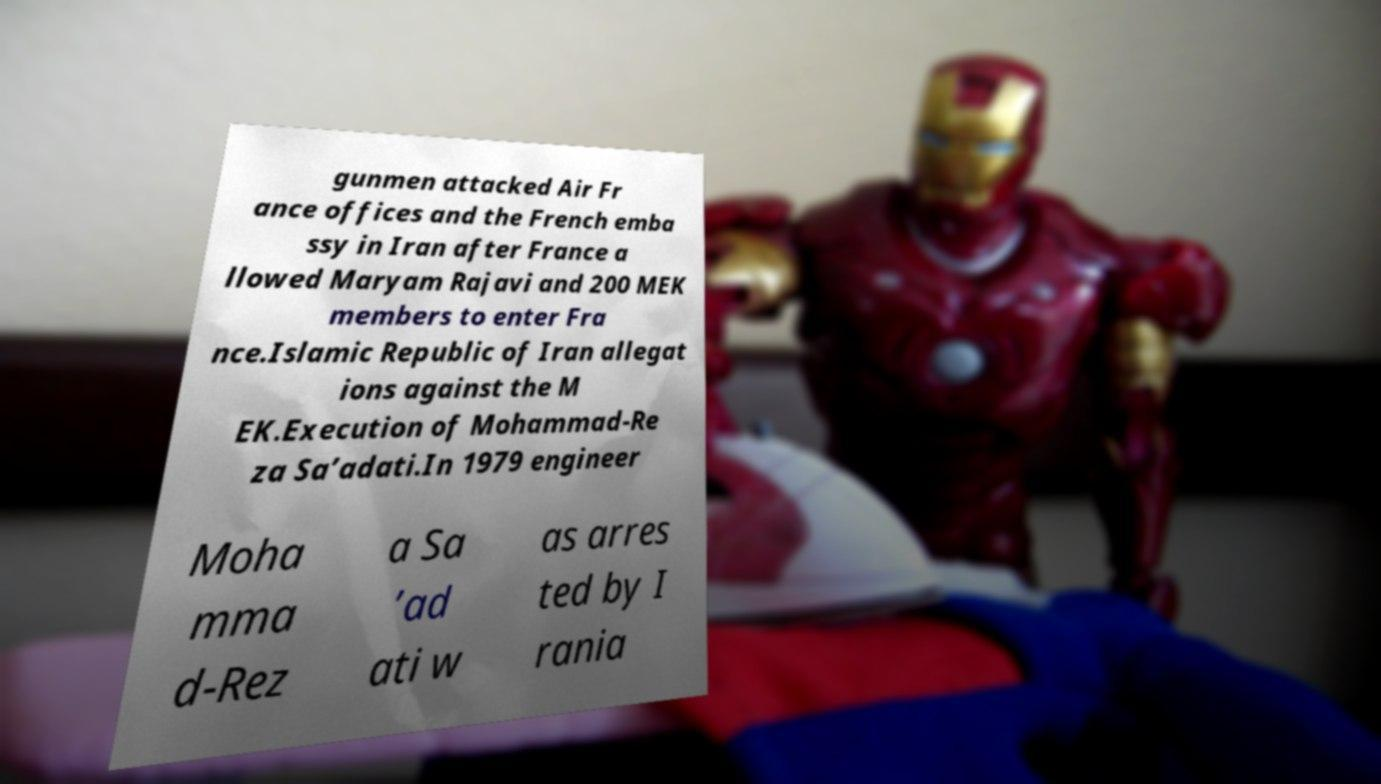There's text embedded in this image that I need extracted. Can you transcribe it verbatim? gunmen attacked Air Fr ance offices and the French emba ssy in Iran after France a llowed Maryam Rajavi and 200 MEK members to enter Fra nce.Islamic Republic of Iran allegat ions against the M EK.Execution of Mohammad-Re za Sa’adati.In 1979 engineer Moha mma d-Rez a Sa ’ad ati w as arres ted by I rania 